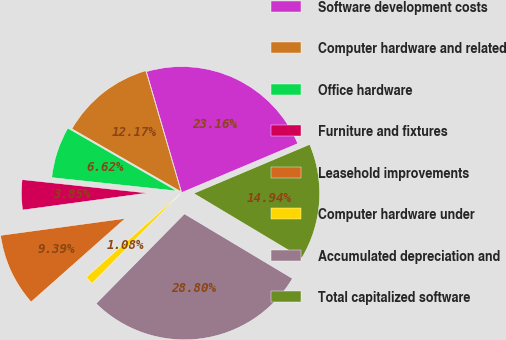<chart> <loc_0><loc_0><loc_500><loc_500><pie_chart><fcel>Software development costs<fcel>Computer hardware and related<fcel>Office hardware<fcel>Furniture and fixtures<fcel>Leasehold improvements<fcel>Computer hardware under<fcel>Accumulated depreciation and<fcel>Total capitalized software<nl><fcel>23.16%<fcel>12.17%<fcel>6.62%<fcel>3.85%<fcel>9.39%<fcel>1.08%<fcel>28.8%<fcel>14.94%<nl></chart> 